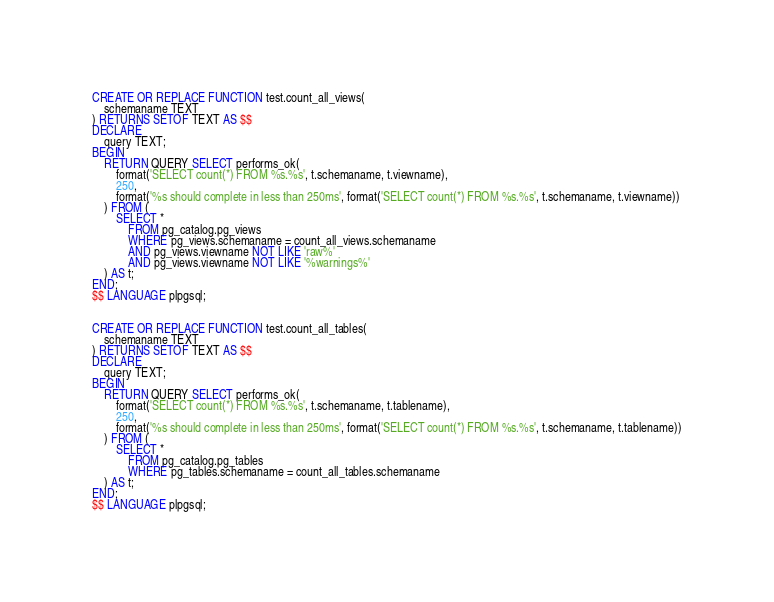Convert code to text. <code><loc_0><loc_0><loc_500><loc_500><_SQL_>CREATE OR REPLACE FUNCTION test.count_all_views(
	schemaname TEXT
) RETURNS SETOF TEXT AS $$
DECLARE
	query TEXT;
BEGIN
	RETURN QUERY SELECT performs_ok(
	    format('SELECT count(*) FROM %s.%s', t.schemaname, t.viewname),
	    250,
	    format('%s should complete in less than 250ms', format('SELECT count(*) FROM %s.%s', t.schemaname, t.viewname))
	) FROM (
		SELECT *
			FROM pg_catalog.pg_views
			WHERE pg_views.schemaname = count_all_views.schemaname
			AND pg_views.viewname NOT LIKE 'raw%'
			AND pg_views.viewname NOT LIKE '%warnings%'
	) AS t;
END;
$$ LANGUAGE plpgsql;


CREATE OR REPLACE FUNCTION test.count_all_tables(
	schemaname TEXT
) RETURNS SETOF TEXT AS $$
DECLARE
	query TEXT;
BEGIN
	RETURN QUERY SELECT performs_ok(
	    format('SELECT count(*) FROM %s.%s', t.schemaname, t.tablename),
	    250,
	    format('%s should complete in less than 250ms', format('SELECT count(*) FROM %s.%s', t.schemaname, t.tablename))
	) FROM (
		SELECT *
			FROM pg_catalog.pg_tables
			WHERE pg_tables.schemaname = count_all_tables.schemaname
	) AS t;
END;
$$ LANGUAGE plpgsql;
</code> 